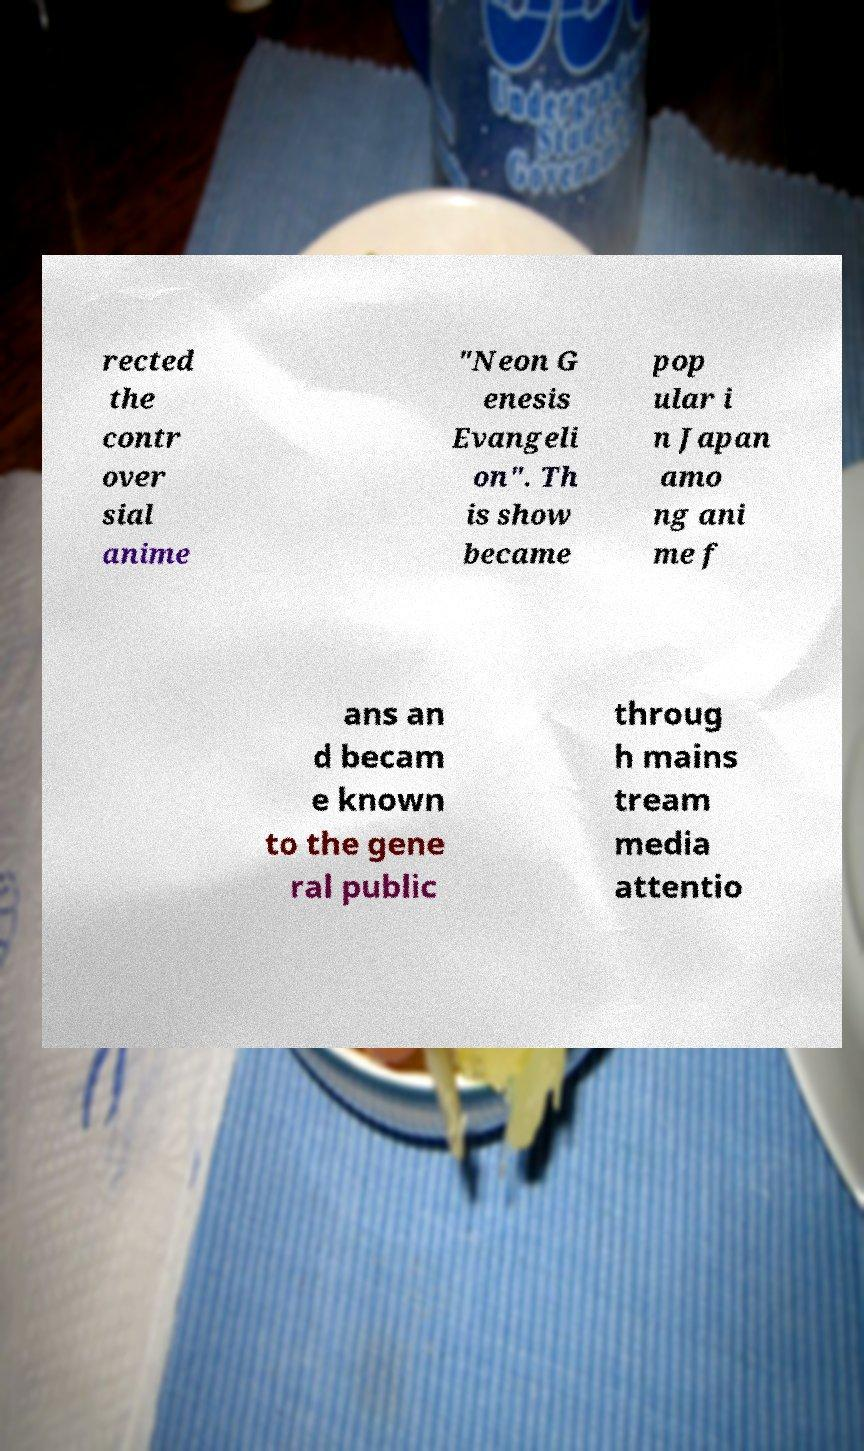Please identify and transcribe the text found in this image. rected the contr over sial anime "Neon G enesis Evangeli on". Th is show became pop ular i n Japan amo ng ani me f ans an d becam e known to the gene ral public throug h mains tream media attentio 